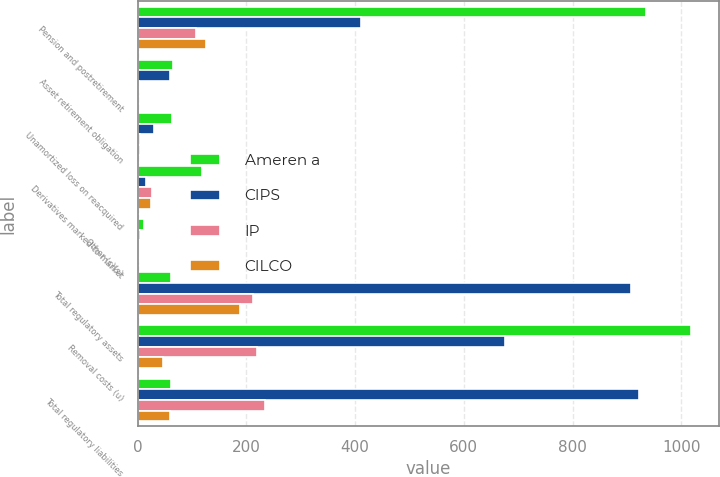Convert chart to OTSL. <chart><loc_0><loc_0><loc_500><loc_500><stacked_bar_chart><ecel><fcel>Pension and postretirement<fcel>Asset retirement obligation<fcel>Unamortized loss on reacquired<fcel>Derivatives marked-to-market<fcel>Other (c)(s)<fcel>Total regulatory assets<fcel>Removal costs (u)<fcel>Total regulatory liabilities<nl><fcel>Ameren a<fcel>936<fcel>65<fcel>63<fcel>118<fcel>11<fcel>61.5<fcel>1018<fcel>61.5<nl><fcel>CIPS<fcel>410<fcel>60<fcel>30<fcel>16<fcel>5<fcel>907<fcel>675<fcel>922<nl><fcel>IP<fcel>107<fcel>2<fcel>5<fcel>27<fcel>2<fcel>212<fcel>220<fcel>234<nl><fcel>CILCO<fcel>125<fcel>1<fcel>5<fcel>25<fcel>2<fcel>188<fcel>47<fcel>59<nl></chart> 